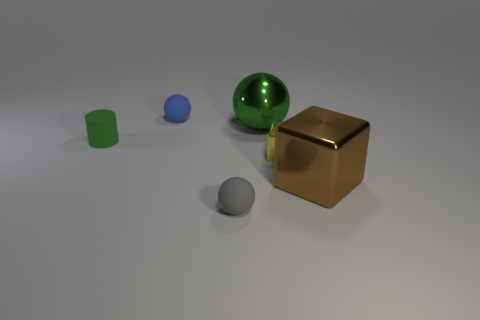Add 3 yellow blocks. How many objects exist? 9 Subtract all blocks. How many objects are left? 4 Add 1 small blocks. How many small blocks exist? 2 Subtract 0 cyan cylinders. How many objects are left? 6 Subtract all small green objects. Subtract all blue matte things. How many objects are left? 4 Add 2 brown blocks. How many brown blocks are left? 3 